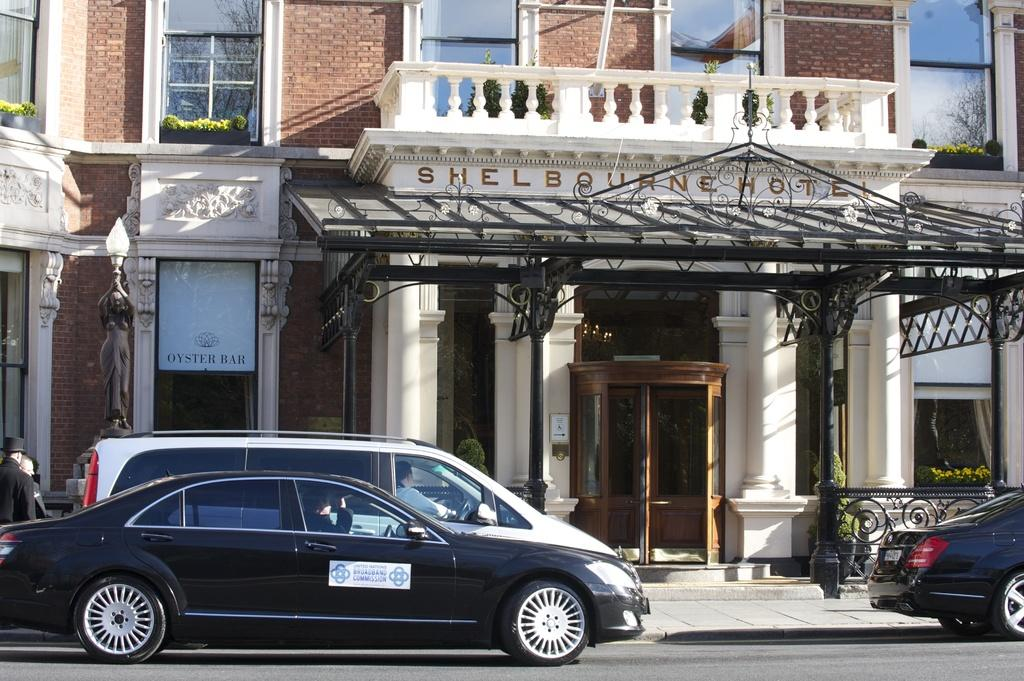What type of structure is present in the image? There is a building in the image. What can be seen in the vicinity of the building? Plants are visible in the image. What mode of transportation can be seen on the road in the image? There are cars on the road in the image. What is hanging on the wall in the image? There is a poster in the image. Who or what is present in the image besides the building and plants? There are people standing in the image. What type of lamp is hanging from the ceiling in the image? There is no lamp present in the image. Can you tell me how many owls are sitting on the poster in the image? There are no owls present in the image; the poster is not described in detail. 